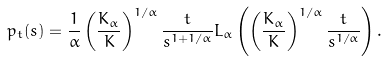Convert formula to latex. <formula><loc_0><loc_0><loc_500><loc_500>p _ { t } ( s ) = \frac { 1 } { \alpha } \left ( \frac { K _ { \alpha } } { K } \right ) ^ { 1 / \alpha } \frac { t } { s ^ { 1 + 1 / \alpha } } L _ { \alpha } \left ( \left ( \frac { K _ { \alpha } } { K } \right ) ^ { 1 / \alpha } \frac { t } { s ^ { 1 / \alpha } } \right ) .</formula> 